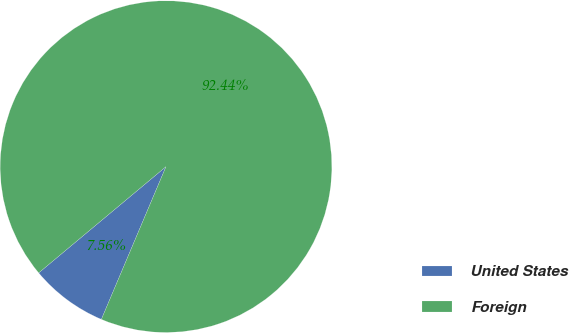Convert chart to OTSL. <chart><loc_0><loc_0><loc_500><loc_500><pie_chart><fcel>United States<fcel>Foreign<nl><fcel>7.56%<fcel>92.44%<nl></chart> 